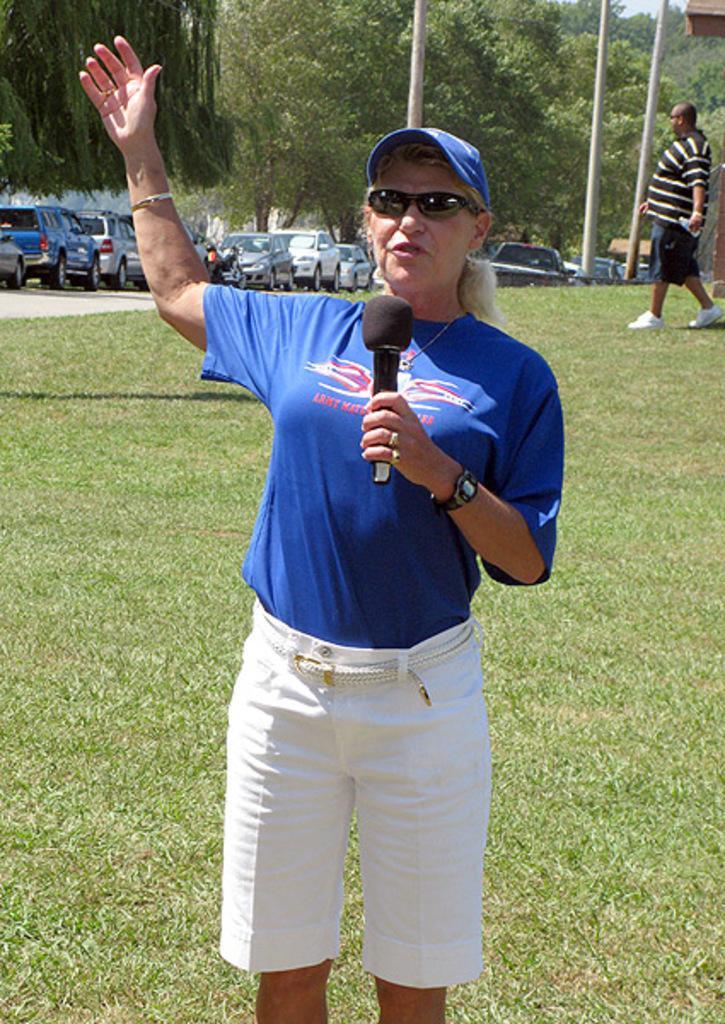Could you give a brief overview of what you see in this image? In the foreground I can see a woman is holding a mike in hand is standing on grass. In the background, I can see fleets of vehicles on the road, light poles, trees, buildings and one person is walking. This image is taken may be during a day. 